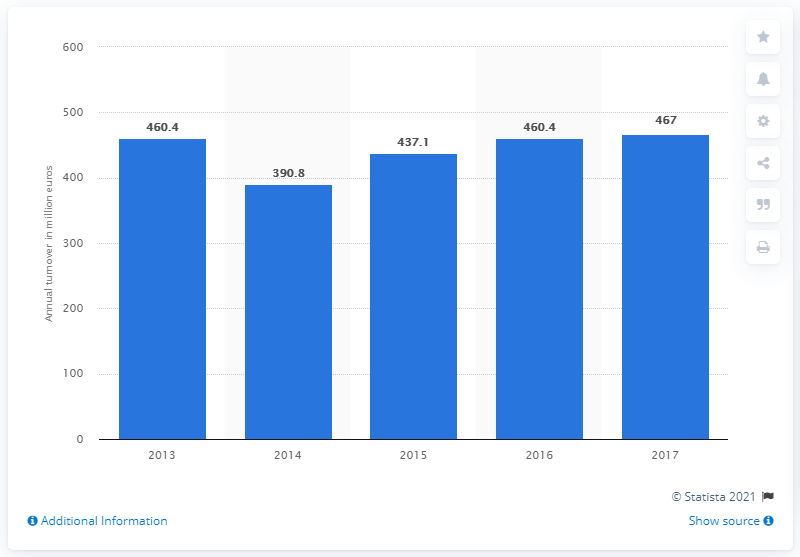Point out several critical features in this image. In 2017, the annual turnover of the Italian Illy coffee company was 467 million euros. In 2014, the annual turnover of the Italian Illy coffee company was 390.8 million euros. 